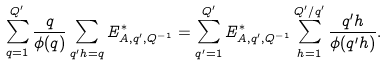Convert formula to latex. <formula><loc_0><loc_0><loc_500><loc_500>\sum _ { q = 1 } ^ { Q ^ { \prime } } { \frac { q } { \phi ( q ) } \sum _ { q ^ { \prime } h = q } { E _ { A , q ^ { \prime } , Q ^ { - 1 } } ^ { * } } } = \sum _ { q ^ { \prime } = 1 } ^ { Q ^ { \prime } } { E _ { A , q ^ { \prime } , Q ^ { - 1 } } ^ { * } \sum _ { h = 1 } ^ { Q ^ { \prime } / q ^ { \prime } } { \frac { q ^ { \prime } h } { \phi ( q ^ { \prime } h ) } } } .</formula> 